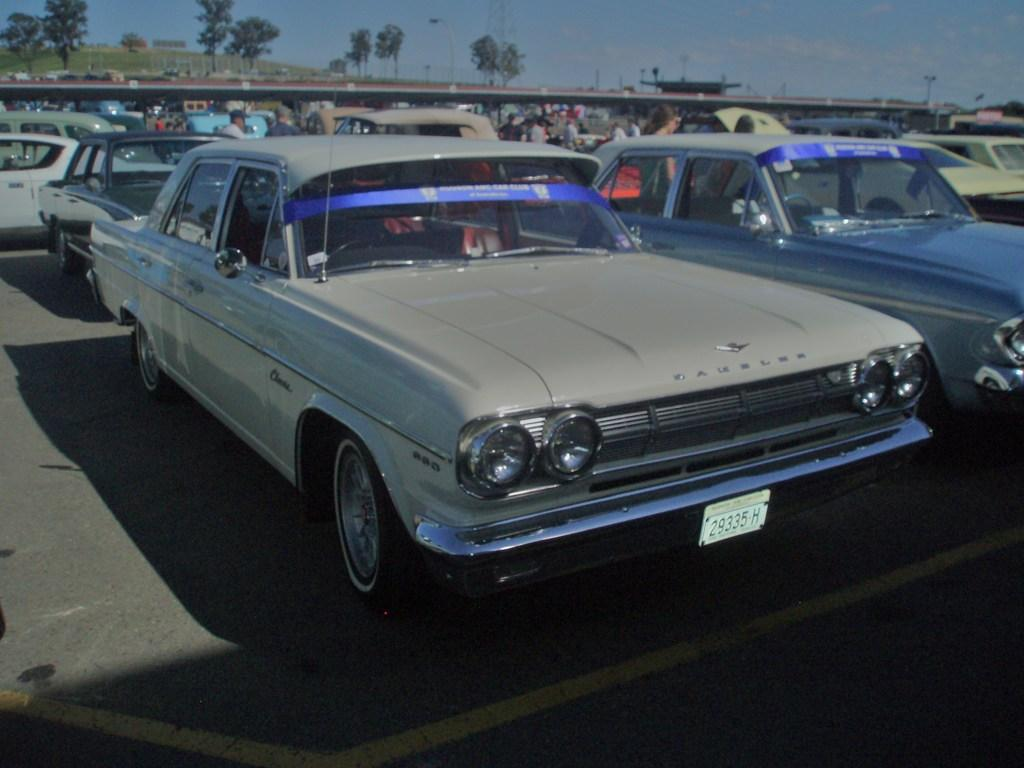Provide a one-sentence caption for the provided image. A row of old fashioned cars in a parking lot and the front plate says 29335H. 